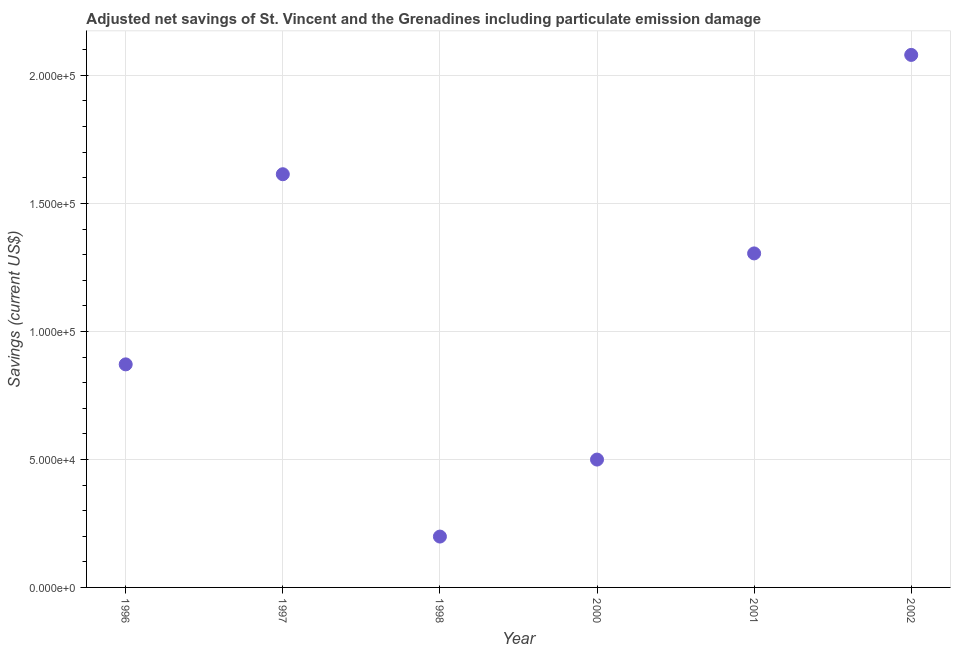What is the adjusted net savings in 1997?
Your answer should be compact. 1.61e+05. Across all years, what is the maximum adjusted net savings?
Provide a short and direct response. 2.08e+05. Across all years, what is the minimum adjusted net savings?
Give a very brief answer. 1.99e+04. In which year was the adjusted net savings minimum?
Your response must be concise. 1998. What is the sum of the adjusted net savings?
Your response must be concise. 6.57e+05. What is the difference between the adjusted net savings in 1997 and 1998?
Your answer should be very brief. 1.42e+05. What is the average adjusted net savings per year?
Provide a succinct answer. 1.09e+05. What is the median adjusted net savings?
Offer a very short reply. 1.09e+05. Do a majority of the years between 1996 and 1998 (inclusive) have adjusted net savings greater than 100000 US$?
Provide a succinct answer. No. What is the ratio of the adjusted net savings in 1998 to that in 2001?
Keep it short and to the point. 0.15. Is the adjusted net savings in 1997 less than that in 1998?
Give a very brief answer. No. What is the difference between the highest and the second highest adjusted net savings?
Your response must be concise. 4.66e+04. What is the difference between the highest and the lowest adjusted net savings?
Give a very brief answer. 1.88e+05. In how many years, is the adjusted net savings greater than the average adjusted net savings taken over all years?
Make the answer very short. 3. Does the adjusted net savings monotonically increase over the years?
Offer a very short reply. No. How many dotlines are there?
Your answer should be very brief. 1. Are the values on the major ticks of Y-axis written in scientific E-notation?
Offer a very short reply. Yes. Does the graph contain any zero values?
Make the answer very short. No. What is the title of the graph?
Your response must be concise. Adjusted net savings of St. Vincent and the Grenadines including particulate emission damage. What is the label or title of the X-axis?
Offer a terse response. Year. What is the label or title of the Y-axis?
Provide a succinct answer. Savings (current US$). What is the Savings (current US$) in 1996?
Give a very brief answer. 8.71e+04. What is the Savings (current US$) in 1997?
Your answer should be compact. 1.61e+05. What is the Savings (current US$) in 1998?
Ensure brevity in your answer.  1.99e+04. What is the Savings (current US$) in 2000?
Make the answer very short. 4.99e+04. What is the Savings (current US$) in 2001?
Your answer should be very brief. 1.30e+05. What is the Savings (current US$) in 2002?
Your answer should be very brief. 2.08e+05. What is the difference between the Savings (current US$) in 1996 and 1997?
Offer a very short reply. -7.43e+04. What is the difference between the Savings (current US$) in 1996 and 1998?
Ensure brevity in your answer.  6.73e+04. What is the difference between the Savings (current US$) in 1996 and 2000?
Make the answer very short. 3.72e+04. What is the difference between the Savings (current US$) in 1996 and 2001?
Give a very brief answer. -4.33e+04. What is the difference between the Savings (current US$) in 1996 and 2002?
Provide a short and direct response. -1.21e+05. What is the difference between the Savings (current US$) in 1997 and 1998?
Offer a terse response. 1.42e+05. What is the difference between the Savings (current US$) in 1997 and 2000?
Your response must be concise. 1.11e+05. What is the difference between the Savings (current US$) in 1997 and 2001?
Give a very brief answer. 3.09e+04. What is the difference between the Savings (current US$) in 1997 and 2002?
Give a very brief answer. -4.66e+04. What is the difference between the Savings (current US$) in 1998 and 2000?
Provide a succinct answer. -3.01e+04. What is the difference between the Savings (current US$) in 1998 and 2001?
Keep it short and to the point. -1.11e+05. What is the difference between the Savings (current US$) in 1998 and 2002?
Your response must be concise. -1.88e+05. What is the difference between the Savings (current US$) in 2000 and 2001?
Give a very brief answer. -8.05e+04. What is the difference between the Savings (current US$) in 2000 and 2002?
Offer a terse response. -1.58e+05. What is the difference between the Savings (current US$) in 2001 and 2002?
Your answer should be very brief. -7.75e+04. What is the ratio of the Savings (current US$) in 1996 to that in 1997?
Your response must be concise. 0.54. What is the ratio of the Savings (current US$) in 1996 to that in 1998?
Provide a succinct answer. 4.39. What is the ratio of the Savings (current US$) in 1996 to that in 2000?
Your answer should be very brief. 1.75. What is the ratio of the Savings (current US$) in 1996 to that in 2001?
Offer a very short reply. 0.67. What is the ratio of the Savings (current US$) in 1996 to that in 2002?
Offer a terse response. 0.42. What is the ratio of the Savings (current US$) in 1997 to that in 1998?
Ensure brevity in your answer.  8.12. What is the ratio of the Savings (current US$) in 1997 to that in 2000?
Offer a very short reply. 3.23. What is the ratio of the Savings (current US$) in 1997 to that in 2001?
Your answer should be compact. 1.24. What is the ratio of the Savings (current US$) in 1997 to that in 2002?
Keep it short and to the point. 0.78. What is the ratio of the Savings (current US$) in 1998 to that in 2000?
Offer a terse response. 0.4. What is the ratio of the Savings (current US$) in 1998 to that in 2001?
Keep it short and to the point. 0.15. What is the ratio of the Savings (current US$) in 1998 to that in 2002?
Provide a succinct answer. 0.1. What is the ratio of the Savings (current US$) in 2000 to that in 2001?
Provide a short and direct response. 0.38. What is the ratio of the Savings (current US$) in 2000 to that in 2002?
Make the answer very short. 0.24. What is the ratio of the Savings (current US$) in 2001 to that in 2002?
Provide a short and direct response. 0.63. 